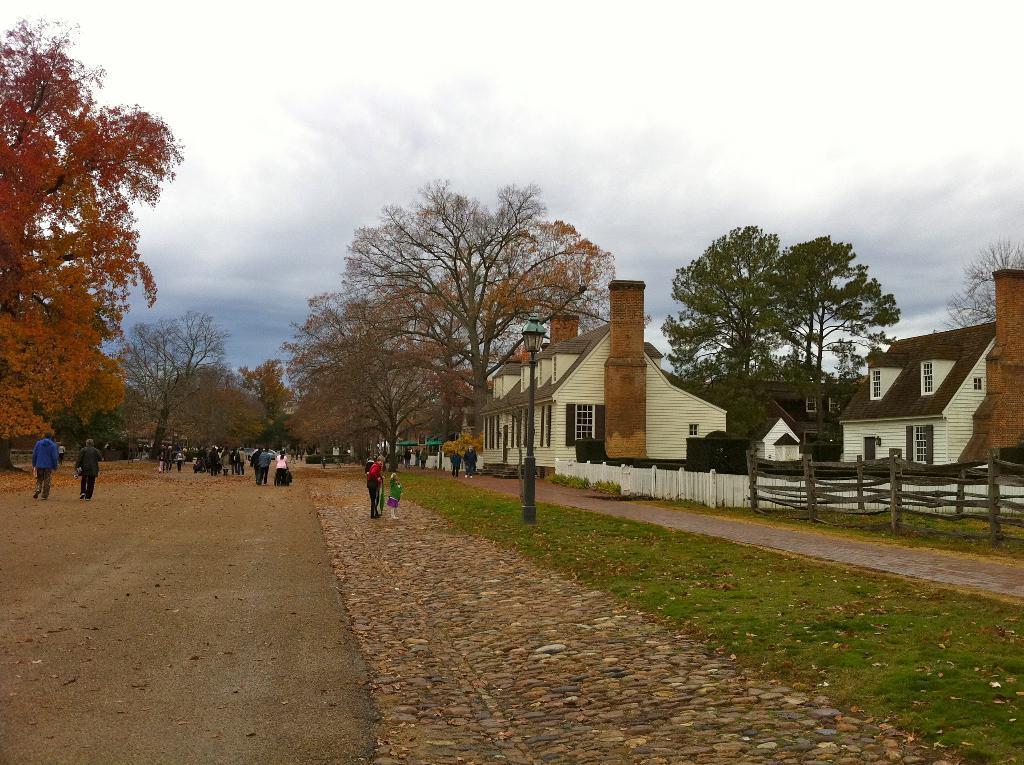In one or two sentences, can you explain what this image depicts? In this image there are few persons walking on the road. Few persons are on the pavement. There is a street light on the grassland. Right side there is a fence. Behind there are few buildings. Background there are few trees. Top of the image there is sky. 